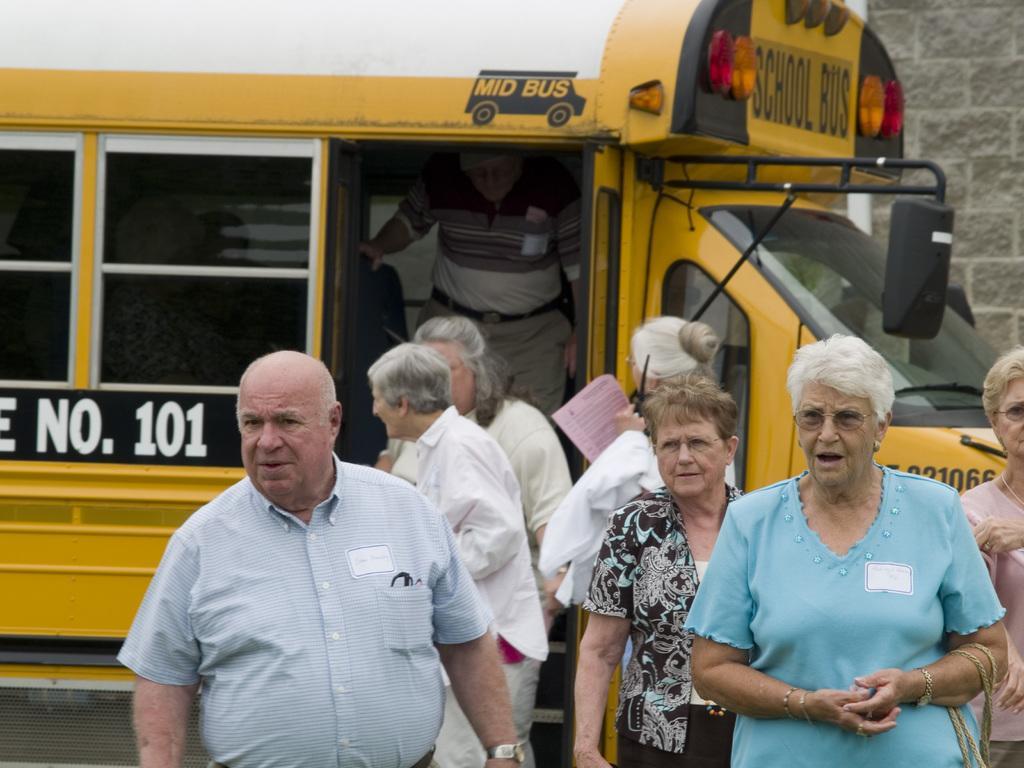In one or two sentences, can you explain what this image depicts? In this picture we can see few people and a vehicle. In the background there is a wall. 